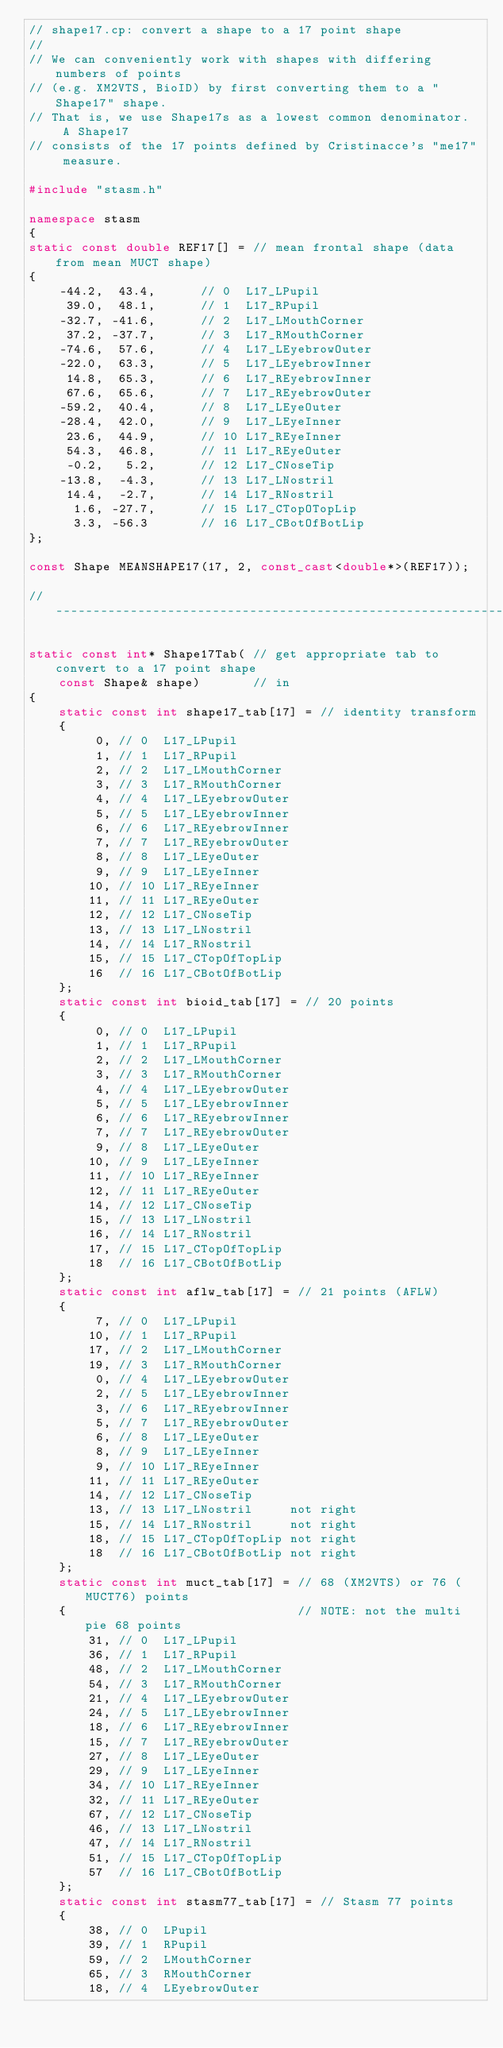<code> <loc_0><loc_0><loc_500><loc_500><_C++_>// shape17.cp: convert a shape to a 17 point shape
//
// We can conveniently work with shapes with differing numbers of points
// (e.g. XM2VTS, BioID) by first converting them to a "Shape17" shape.
// That is, we use Shape17s as a lowest common denominator.  A Shape17
// consists of the 17 points defined by Cristinacce's "me17" measure.

#include "stasm.h"

namespace stasm
{
static const double REF17[] = // mean frontal shape (data from mean MUCT shape)
{
    -44.2,  43.4,      // 0  L17_LPupil
     39.0,  48.1,      // 1  L17_RPupil
    -32.7, -41.6,      // 2  L17_LMouthCorner
     37.2, -37.7,      // 3  L17_RMouthCorner
    -74.6,  57.6,      // 4  L17_LEyebrowOuter
    -22.0,  63.3,      // 5  L17_LEyebrowInner
     14.8,  65.3,      // 6  L17_REyebrowInner
     67.6,  65.6,      // 7  L17_REyebrowOuter
    -59.2,  40.4,      // 8  L17_LEyeOuter
    -28.4,  42.0,      // 9  L17_LEyeInner
     23.6,  44.9,      // 10 L17_REyeInner
     54.3,  46.8,      // 11 L17_REyeOuter
     -0.2,   5.2,      // 12 L17_CNoseTip
    -13.8,  -4.3,      // 13 L17_LNostril
     14.4,  -2.7,      // 14 L17_RNostril
      1.6, -27.7,      // 15 L17_CTopOTopLip
      3.3, -56.3       // 16 L17_CBotOfBotLip
};

const Shape MEANSHAPE17(17, 2, const_cast<double*>(REF17));

//-----------------------------------------------------------------------------

static const int* Shape17Tab( // get appropriate tab to convert to a 17 point shape
    const Shape& shape)       // in
{
    static const int shape17_tab[17] = // identity transform
    {
         0, // 0  L17_LPupil
         1, // 1  L17_RPupil
         2, // 2  L17_LMouthCorner
         3, // 3  L17_RMouthCorner
         4, // 4  L17_LEyebrowOuter
         5, // 5  L17_LEyebrowInner
         6, // 6  L17_REyebrowInner
         7, // 7  L17_REyebrowOuter
         8, // 8  L17_LEyeOuter
         9, // 9  L17_LEyeInner
        10, // 10 L17_REyeInner
        11, // 11 L17_REyeOuter
        12, // 12 L17_CNoseTip
        13, // 13 L17_LNostril
        14, // 14 L17_RNostril
        15, // 15 L17_CTopOfTopLip
        16  // 16 L17_CBotOfBotLip
    };
    static const int bioid_tab[17] = // 20 points
    {
         0, // 0  L17_LPupil
         1, // 1  L17_RPupil
         2, // 2  L17_LMouthCorner
         3, // 3  L17_RMouthCorner
         4, // 4  L17_LEyebrowOuter
         5, // 5  L17_LEyebrowInner
         6, // 6  L17_REyebrowInner
         7, // 7  L17_REyebrowOuter
         9, // 8  L17_LEyeOuter
        10, // 9  L17_LEyeInner
        11, // 10 L17_REyeInner
        12, // 11 L17_REyeOuter
        14, // 12 L17_CNoseTip
        15, // 13 L17_LNostril
        16, // 14 L17_RNostril
        17, // 15 L17_CTopOfTopLip
        18  // 16 L17_CBotOfBotLip
    };
    static const int aflw_tab[17] = // 21 points (AFLW)
    {
         7, // 0  L17_LPupil
        10, // 1  L17_RPupil
        17, // 2  L17_LMouthCorner
        19, // 3  L17_RMouthCorner
         0, // 4  L17_LEyebrowOuter
         2, // 5  L17_LEyebrowInner
         3, // 6  L17_REyebrowInner
         5, // 7  L17_REyebrowOuter
         6, // 8  L17_LEyeOuter
         8, // 9  L17_LEyeInner
         9, // 10 L17_REyeInner
        11, // 11 L17_REyeOuter
        14, // 12 L17_CNoseTip
        13, // 13 L17_LNostril     not right
        15, // 14 L17_RNostril     not right
        18, // 15 L17_CTopOfTopLip not right
        18  // 16 L17_CBotOfBotLip not right
    };
    static const int muct_tab[17] = // 68 (XM2VTS) or 76 (MUCT76) points
    {                               // NOTE: not the multi pie 68 points
        31, // 0  L17_LPupil
        36, // 1  L17_RPupil
        48, // 2  L17_LMouthCorner
        54, // 3  L17_RMouthCorner
        21, // 4  L17_LEyebrowOuter
        24, // 5  L17_LEyebrowInner
        18, // 6  L17_REyebrowInner
        15, // 7  L17_REyebrowOuter
        27, // 8  L17_LEyeOuter
        29, // 9  L17_LEyeInner
        34, // 10 L17_REyeInner
        32, // 11 L17_REyeOuter
        67, // 12 L17_CNoseTip
        46, // 13 L17_LNostril
        47, // 14 L17_RNostril
        51, // 15 L17_CTopOfTopLip
        57  // 16 L17_CBotOfBotLip
    };
    static const int stasm77_tab[17] = // Stasm 77 points
    {
        38, // 0  LPupil
        39, // 1  RPupil
        59, // 2  LMouthCorner
        65, // 3  RMouthCorner
        18, // 4  LEyebrowOuter</code> 